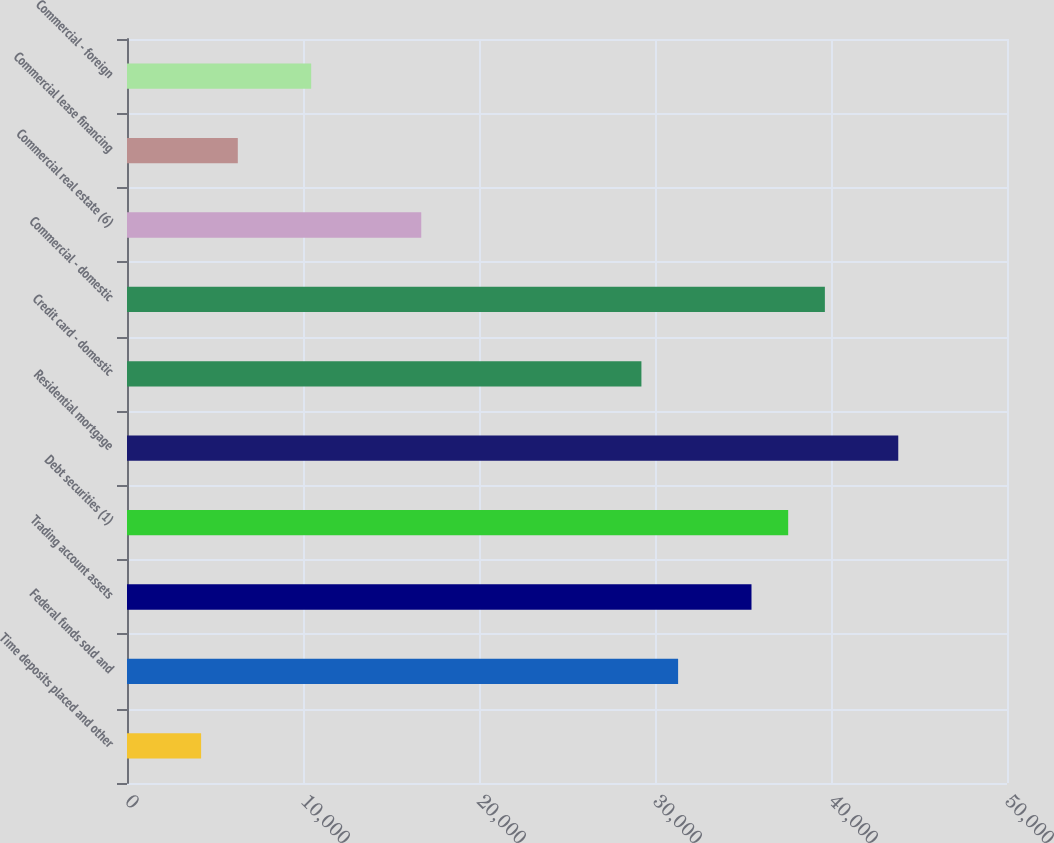Convert chart. <chart><loc_0><loc_0><loc_500><loc_500><bar_chart><fcel>Time deposits placed and other<fcel>Federal funds sold and<fcel>Trading account assets<fcel>Debt securities (1)<fcel>Residential mortgage<fcel>Credit card - domestic<fcel>Commercial - domestic<fcel>Commercial real estate (6)<fcel>Commercial lease financing<fcel>Commercial - foreign<nl><fcel>4210.6<fcel>31313<fcel>35482.6<fcel>37567.4<fcel>43821.8<fcel>29228.2<fcel>39652.2<fcel>16719.4<fcel>6295.4<fcel>10465<nl></chart> 